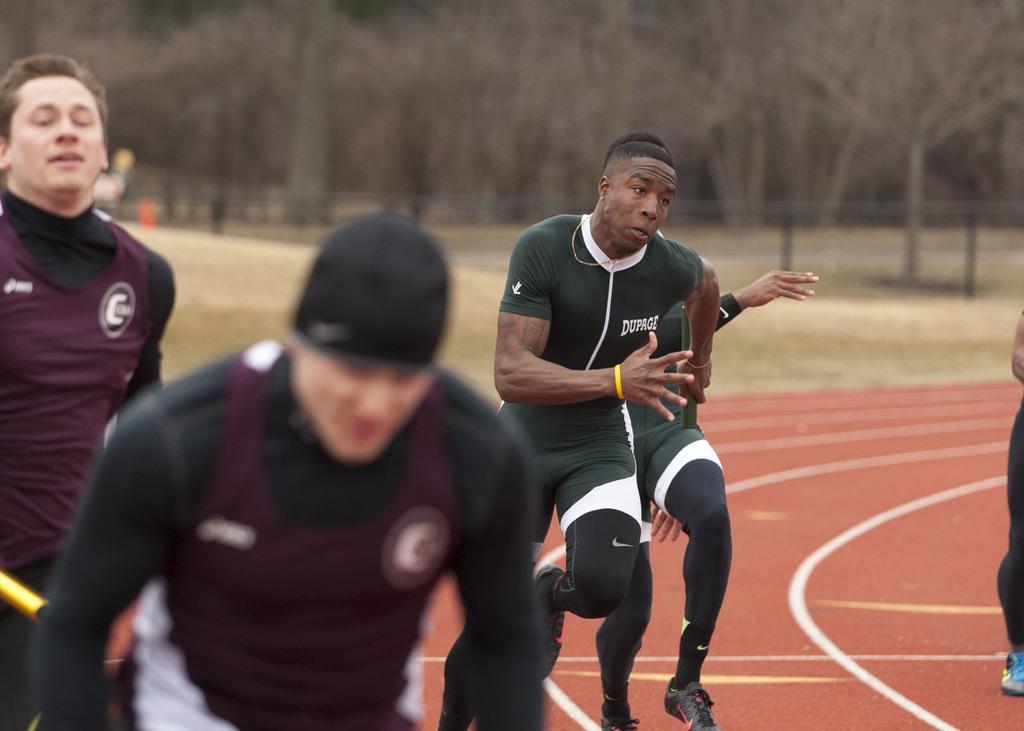Could you give a brief overview of what you see in this image? In this picture I can see group of people running on the track, and in the background there are trees. 